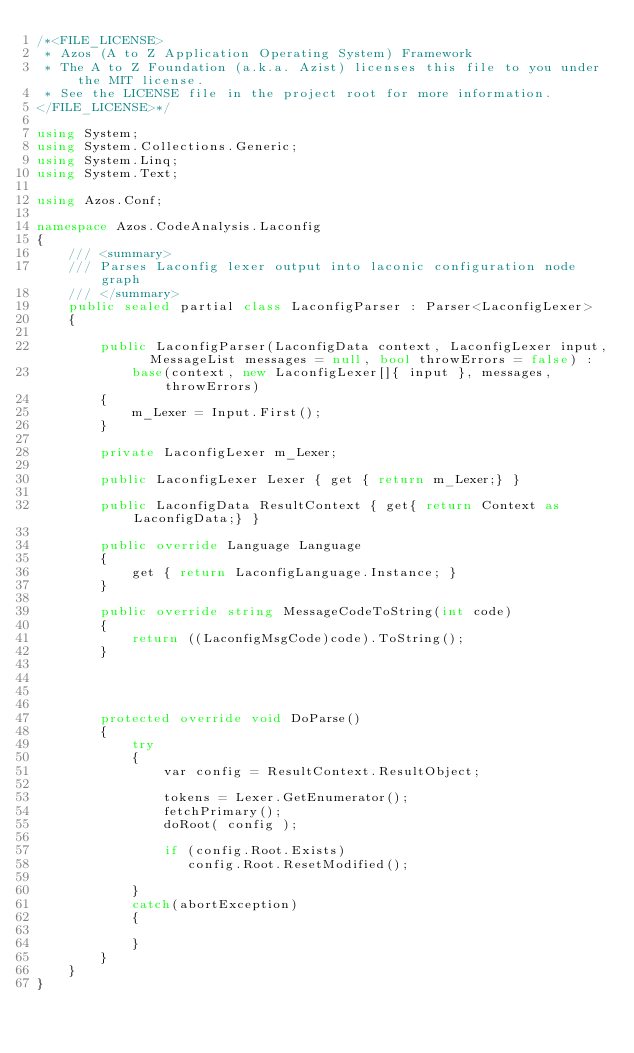<code> <loc_0><loc_0><loc_500><loc_500><_C#_>/*<FILE_LICENSE>
 * Azos (A to Z Application Operating System) Framework
 * The A to Z Foundation (a.k.a. Azist) licenses this file to you under the MIT license.
 * See the LICENSE file in the project root for more information.
</FILE_LICENSE>*/

using System;
using System.Collections.Generic;
using System.Linq;
using System.Text;

using Azos.Conf;

namespace Azos.CodeAnalysis.Laconfig
{
    /// <summary>
    /// Parses Laconfig lexer output into laconic configuration node graph
    /// </summary>
    public sealed partial class LaconfigParser : Parser<LaconfigLexer>
    {

        public LaconfigParser(LaconfigData context, LaconfigLexer input,  MessageList messages = null, bool throwErrors = false) :
            base(context, new LaconfigLexer[]{ input }, messages, throwErrors)
        {
            m_Lexer = Input.First();
        }

        private LaconfigLexer m_Lexer;

        public LaconfigLexer Lexer { get { return m_Lexer;} }

        public LaconfigData ResultContext { get{ return Context as LaconfigData;} }

        public override Language Language
        {
            get { return LaconfigLanguage.Instance; }
        }

        public override string MessageCodeToString(int code)
        {
            return ((LaconfigMsgCode)code).ToString();
        }




        protected override void DoParse()
        {
            try
            {
                var config = ResultContext.ResultObject;

                tokens = Lexer.GetEnumerator();
                fetchPrimary();
                doRoot( config );

                if (config.Root.Exists)
                   config.Root.ResetModified();

            }
            catch(abortException)
            {

            }
        }
    }
}
</code> 